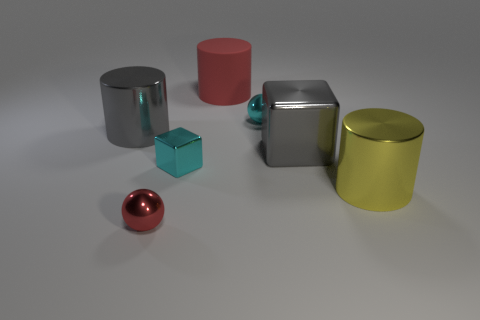Subtract all metallic cylinders. How many cylinders are left? 1 Subtract all red matte objects. Subtract all cyan blocks. How many objects are left? 5 Add 2 small blocks. How many small blocks are left? 3 Add 6 red objects. How many red objects exist? 8 Add 1 large cubes. How many objects exist? 8 Subtract all gray blocks. How many blocks are left? 1 Subtract 0 brown blocks. How many objects are left? 7 Subtract all balls. How many objects are left? 5 Subtract 1 cubes. How many cubes are left? 1 Subtract all purple cylinders. Subtract all green spheres. How many cylinders are left? 3 